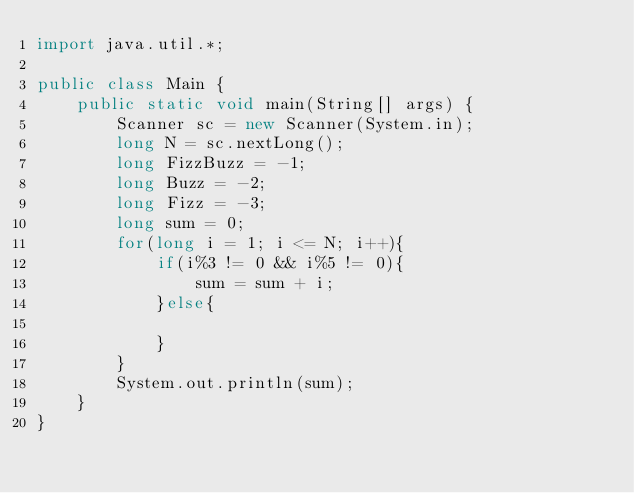Convert code to text. <code><loc_0><loc_0><loc_500><loc_500><_Java_>import java.util.*;

public class Main {
    public static void main(String[] args) {
        Scanner sc = new Scanner(System.in);
        long N = sc.nextLong();
        long FizzBuzz = -1;
        long Buzz = -2;
        long Fizz = -3;
        long sum = 0;
        for(long i = 1; i <= N; i++){
            if(i%3 != 0 && i%5 != 0){
                sum = sum + i;
            }else{

            }
        }
        System.out.println(sum);
    }
} </code> 